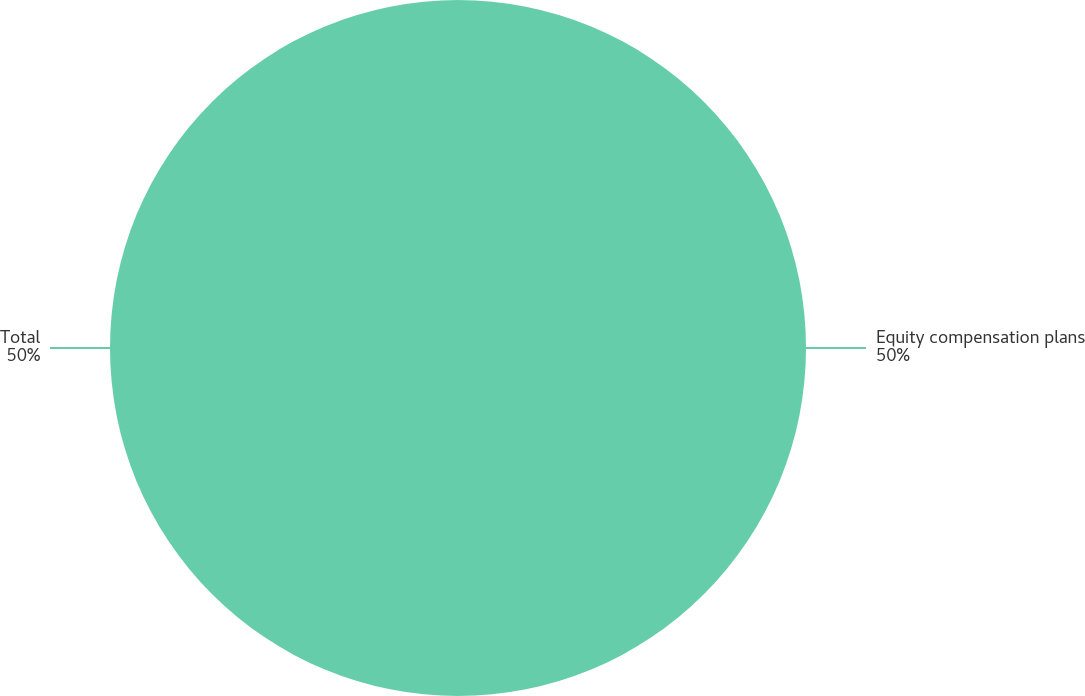Convert chart. <chart><loc_0><loc_0><loc_500><loc_500><pie_chart><fcel>Equity compensation plans<fcel>Total<nl><fcel>50.0%<fcel>50.0%<nl></chart> 